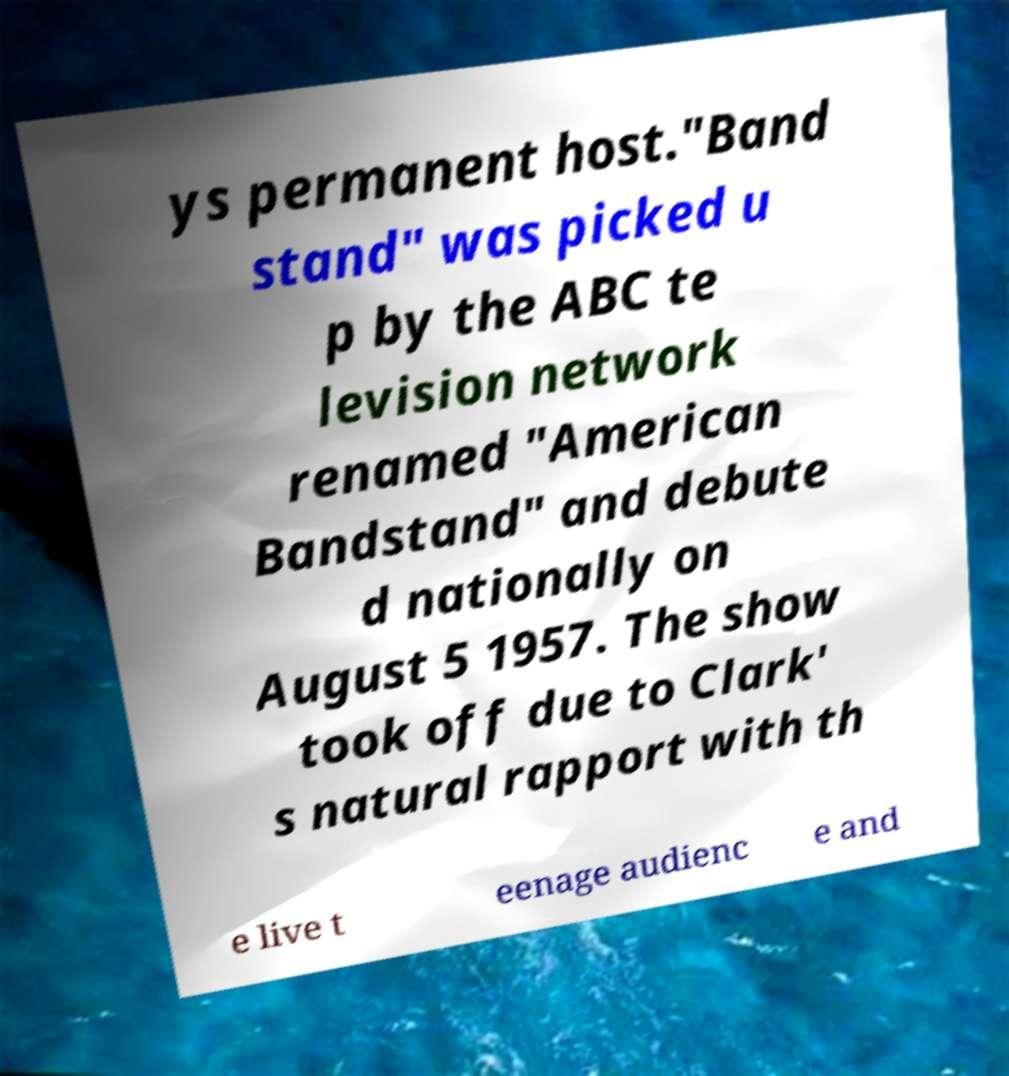Can you accurately transcribe the text from the provided image for me? ys permanent host."Band stand" was picked u p by the ABC te levision network renamed "American Bandstand" and debute d nationally on August 5 1957. The show took off due to Clark' s natural rapport with th e live t eenage audienc e and 